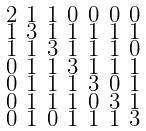Convert formula to latex. <formula><loc_0><loc_0><loc_500><loc_500>\begin{smallmatrix} 2 & 1 & 1 & 0 & 0 & 0 & 0 \\ 1 & 3 & 1 & 1 & 1 & 1 & 1 \\ 1 & 1 & 3 & 1 & 1 & 1 & 0 \\ 0 & 1 & 1 & 3 & 1 & 1 & 1 \\ 0 & 1 & 1 & 1 & 3 & 0 & 1 \\ 0 & 1 & 1 & 1 & 0 & 3 & 1 \\ 0 & 1 & 0 & 1 & 1 & 1 & 3 \end{smallmatrix}</formula> 